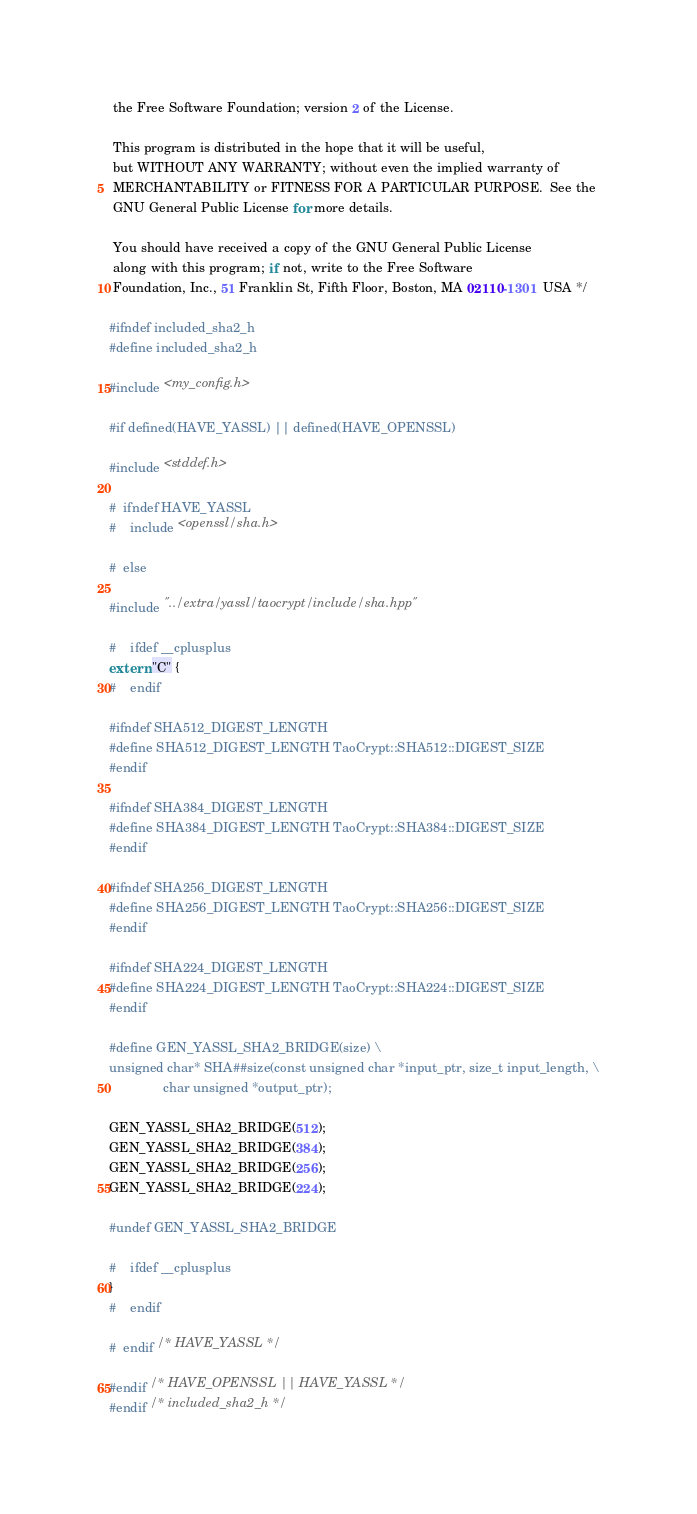<code> <loc_0><loc_0><loc_500><loc_500><_C_> the Free Software Foundation; version 2 of the License.

 This program is distributed in the hope that it will be useful,
 but WITHOUT ANY WARRANTY; without even the implied warranty of
 MERCHANTABILITY or FITNESS FOR A PARTICULAR PURPOSE.  See the
 GNU General Public License for more details.

 You should have received a copy of the GNU General Public License
 along with this program; if not, write to the Free Software
 Foundation, Inc., 51 Franklin St, Fifth Floor, Boston, MA 02110-1301  USA */

#ifndef included_sha2_h
#define included_sha2_h

#include <my_config.h>

#if defined(HAVE_YASSL) || defined(HAVE_OPENSSL)

#include <stddef.h>

#  ifndef HAVE_YASSL
#    include <openssl/sha.h>

#  else

#include "../extra/yassl/taocrypt/include/sha.hpp"

#    ifdef __cplusplus
extern "C" {
#    endif

#ifndef SHA512_DIGEST_LENGTH
#define SHA512_DIGEST_LENGTH TaoCrypt::SHA512::DIGEST_SIZE
#endif

#ifndef SHA384_DIGEST_LENGTH
#define SHA384_DIGEST_LENGTH TaoCrypt::SHA384::DIGEST_SIZE
#endif

#ifndef SHA256_DIGEST_LENGTH
#define SHA256_DIGEST_LENGTH TaoCrypt::SHA256::DIGEST_SIZE
#endif

#ifndef SHA224_DIGEST_LENGTH
#define SHA224_DIGEST_LENGTH TaoCrypt::SHA224::DIGEST_SIZE
#endif

#define GEN_YASSL_SHA2_BRIDGE(size) \
unsigned char* SHA##size(const unsigned char *input_ptr, size_t input_length, \
               char unsigned *output_ptr);

GEN_YASSL_SHA2_BRIDGE(512);
GEN_YASSL_SHA2_BRIDGE(384);
GEN_YASSL_SHA2_BRIDGE(256);
GEN_YASSL_SHA2_BRIDGE(224);

#undef GEN_YASSL_SHA2_BRIDGE

#    ifdef __cplusplus
}
#    endif

#  endif /* HAVE_YASSL */

#endif /* HAVE_OPENSSL || HAVE_YASSL */
#endif /* included_sha2_h */
</code> 